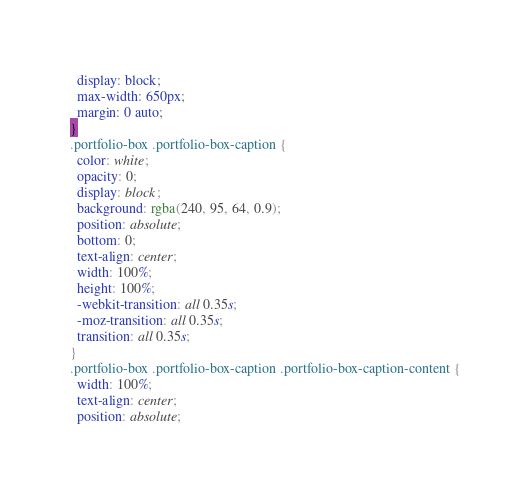Convert code to text. <code><loc_0><loc_0><loc_500><loc_500><_CSS_>  display: block;
  max-width: 650px;
  margin: 0 auto;
}
.portfolio-box .portfolio-box-caption {
  color: white;
  opacity: 0;
  display: block;
  background: rgba(240, 95, 64, 0.9);
  position: absolute;
  bottom: 0;
  text-align: center;
  width: 100%;
  height: 100%;
  -webkit-transition: all 0.35s;
  -moz-transition: all 0.35s;
  transition: all 0.35s;
}
.portfolio-box .portfolio-box-caption .portfolio-box-caption-content {
  width: 100%;
  text-align: center;
  position: absolute;</code> 